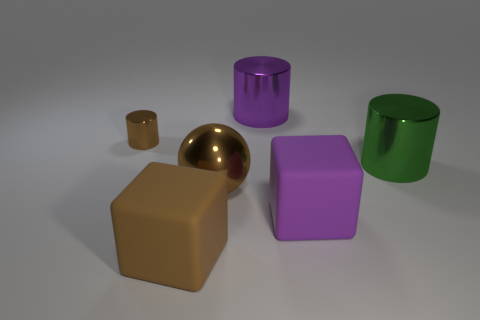There is a big object behind the brown cylinder; what material is it?
Your answer should be very brief. Metal. There is a brown ball that is to the left of the large cylinder behind the tiny brown cylinder; how big is it?
Give a very brief answer. Large. Are there any brown blocks that have the same material as the purple cube?
Your answer should be compact. Yes. What is the shape of the purple thing that is to the right of the big cylinder behind the large cylinder right of the purple metallic thing?
Provide a succinct answer. Cube. There is a rubber thing that is in front of the big purple rubber object; is its color the same as the cylinder that is behind the small cylinder?
Ensure brevity in your answer.  No. Is there anything else that is the same size as the purple rubber thing?
Your response must be concise. Yes. There is a big brown cube; are there any large brown metallic spheres in front of it?
Offer a terse response. No. What number of rubber things have the same shape as the large purple metal object?
Your answer should be very brief. 0. There is a large matte thing that is right of the purple cylinder that is on the right side of the metal ball to the right of the big brown matte cube; what color is it?
Provide a succinct answer. Purple. Does the purple object behind the tiny metallic thing have the same material as the cylinder to the left of the large purple shiny cylinder?
Your response must be concise. Yes. 